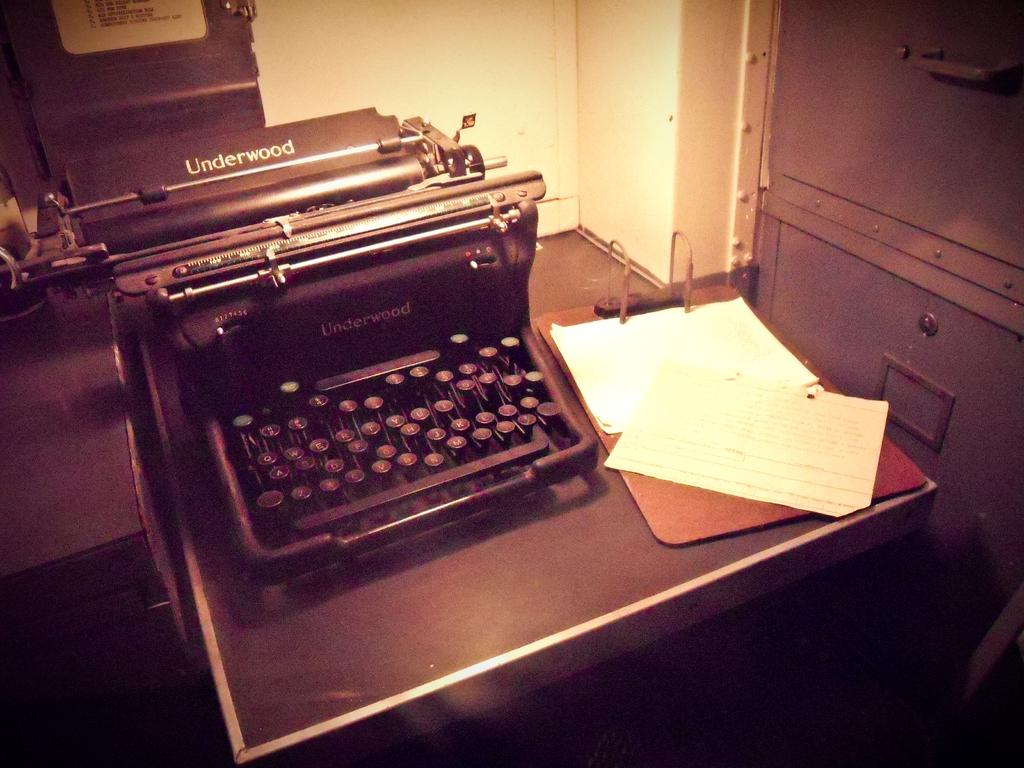<image>
Provide a brief description of the given image. A beat up old antique Underwood manual typewriter. 